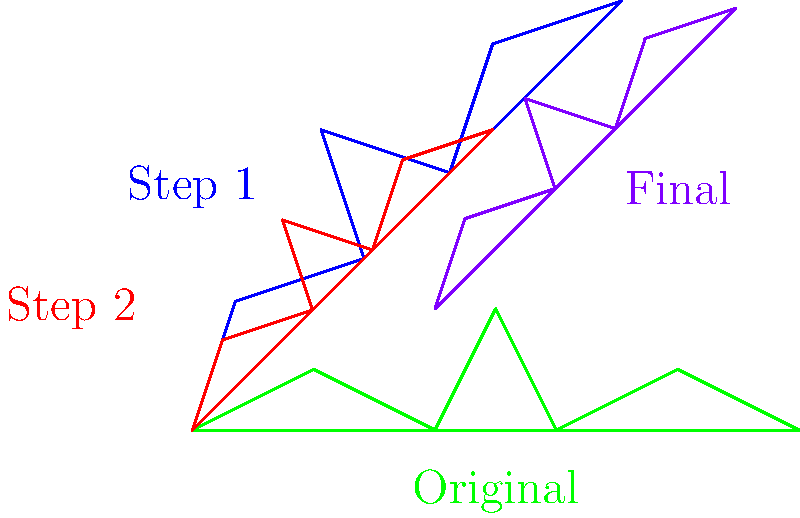In the image above, a frog silhouette undergoes a series of transformations to show different camouflage positions. If the original green frog is transformed to the final purple position, what sequence of transformations was applied, and in what order? Let's break down the transformations step-by-step:

1. The original green frog is first rotated. We can see this in the blue frog, which is tilted at an angle. This is a rotation transformation.

2. The red frog appears to be smaller than the blue frog, maintaining the same angle. This indicates a scaling transformation was applied after the rotation.

3. Finally, the purple frog is in a different position on the coordinate plane compared to the red frog, but maintains the same size and angle. This suggests a translation (shift) was applied last.

To summarize the sequence:
1. Rotation (green to blue)
2. Scaling (blue to red)
3. Translation (red to purple)

The order of these transformations is important because applying them in a different sequence would result in a different final position for the frog.
Answer: Rotation, then scaling, then translation 